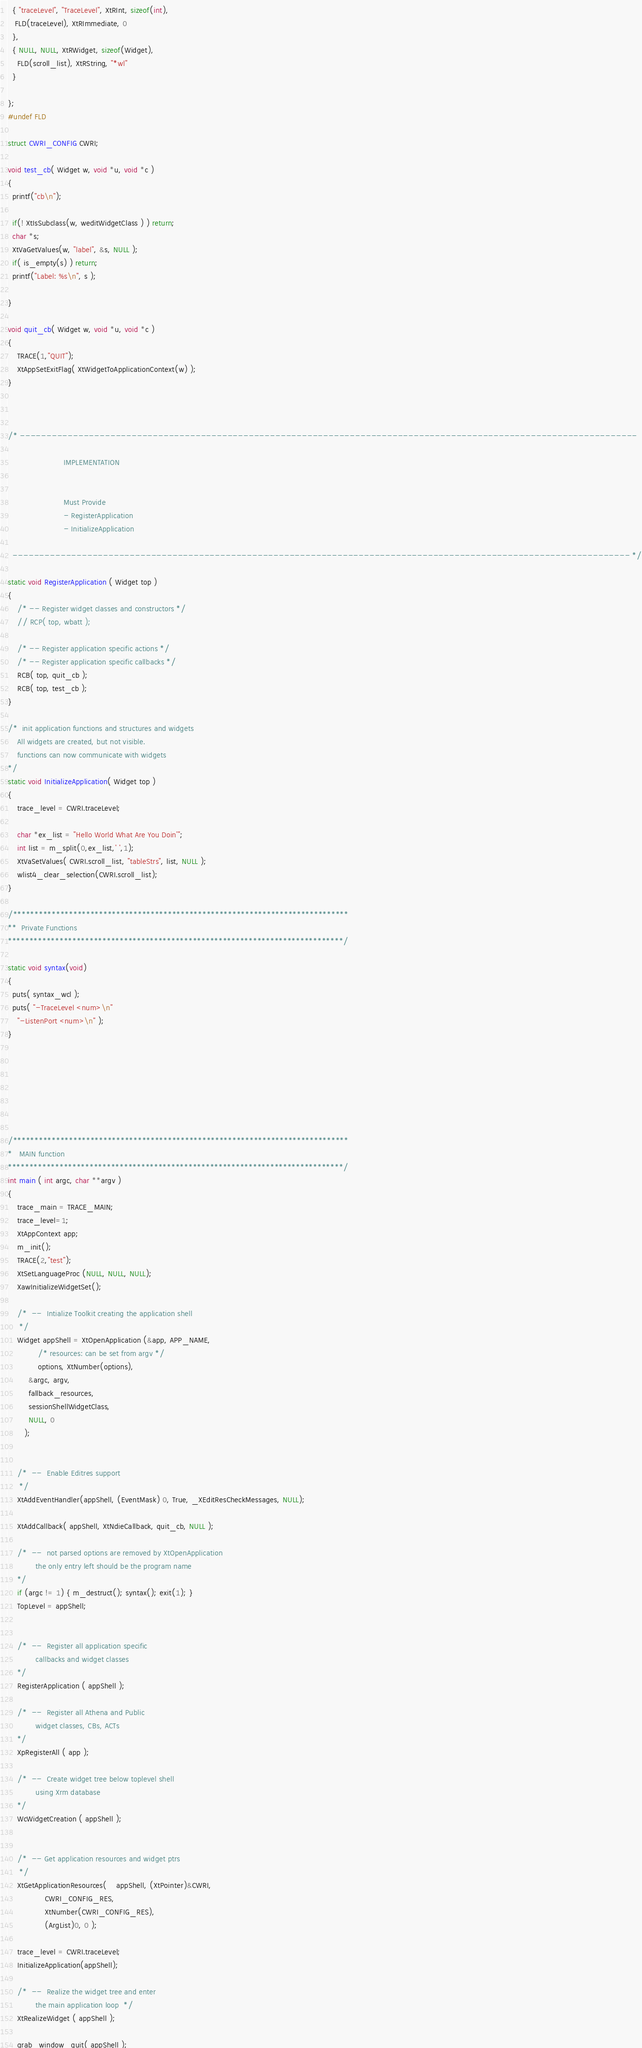Convert code to text. <code><loc_0><loc_0><loc_500><loc_500><_C_>
  { "traceLevel", "TraceLevel", XtRInt, sizeof(int),
   FLD(traceLevel), XtRImmediate, 0
  },
  { NULL, NULL, XtRWidget, sizeof(Widget),
    FLD(scroll_list), XtRString, "*wl"
  }

};
#undef FLD

struct CWRI_CONFIG CWRI;

void test_cb( Widget w, void *u, void *c )
{
  printf("cb\n");

  if(! XtIsSubclass(w, weditWidgetClass ) ) return;
  char *s;
  XtVaGetValues(w, "label", &s, NULL );
  if( is_empty(s) ) return;
  printf("Label: %s\n", s );

}

void quit_cb( Widget w, void *u, void *c )
{
    TRACE(1,"QUIT");
    XtAppSetExitFlag( XtWidgetToApplicationContext(w) );
}



/* --------------------------------------------------------------------------------------------------------------------

                        IMPLEMENTATION


                        Must Provide
                        - RegisterApplication
                        - InitializeApplication

  -------------------------------------------------------------------------------------------------------------------- */

static void RegisterApplication ( Widget top )
{
    /* -- Register widget classes and constructors */
    // RCP( top, wbatt );
    
    /* -- Register application specific actions */
    /* -- Register application specific callbacks */
    RCB( top, quit_cb );
    RCB( top, test_cb );
}

/*  init application functions and structures and widgets
    All widgets are created, but not visible.
    functions can now communicate with widgets
*/
static void InitializeApplication( Widget top )
{
    trace_level = CWRI.traceLevel;

    char *ex_list = "Hello World What Are You Doin'";
    int list = m_split(0,ex_list,' ',1);
    XtVaSetValues( CWRI.scroll_list, "tableStrs", list, NULL );
    wlist4_clear_selection(CWRI.scroll_list);
}

/******************************************************************************
**  Private Functions
******************************************************************************/

static void syntax(void)
{
  puts( syntax_wcl );
  puts( "-TraceLevel <num>\n"
	"-ListenPort <num>\n" );
}







/******************************************************************************
*   MAIN function
******************************************************************************/
int main ( int argc, char **argv )
{
    trace_main = TRACE_MAIN;
    trace_level=1;
    XtAppContext app;
    m_init();
    TRACE(2,"test");
    XtSetLanguageProc (NULL, NULL, NULL);
    XawInitializeWidgetSet();

    /*  --  Intialize Toolkit creating the application shell
     */
    Widget appShell = XtOpenApplication (&app, APP_NAME,
             /* resources: can be set from argv */
             options, XtNumber(options),
	     &argc, argv,
	     fallback_resources,
	     sessionShellWidgetClass,
	     NULL, 0
	   );


    /*  --  Enable Editres support
     */
    XtAddEventHandler(appShell, (EventMask) 0, True, _XEditResCheckMessages, NULL);

    XtAddCallback( appShell, XtNdieCallback, quit_cb, NULL );

    /*  --  not parsed options are removed by XtOpenApplication
            the only entry left should be the program name
    */
    if (argc != 1) { m_destruct(); syntax(); exit(1); }
    TopLevel = appShell;


    /*  --  Register all application specific
            callbacks and widget classes
    */
    RegisterApplication ( appShell );

    /*  --  Register all Athena and Public
            widget classes, CBs, ACTs
    */
    XpRegisterAll ( app );

    /*  --  Create widget tree below toplevel shell
            using Xrm database
    */
    WcWidgetCreation ( appShell );


    /*  -- Get application resources and widget ptrs
     */
    XtGetApplicationResources(	appShell, (XtPointer)&CWRI,
				CWRI_CONFIG_RES,
				XtNumber(CWRI_CONFIG_RES),
				(ArgList)0, 0 );

    trace_level = CWRI.traceLevel;
    InitializeApplication(appShell);

    /*  --  Realize the widget tree and enter
            the main application loop  */
    XtRealizeWidget ( appShell );

    grab_window_quit( appShell );
</code> 